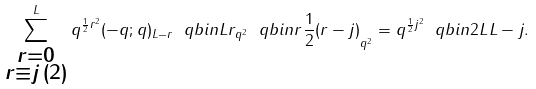Convert formula to latex. <formula><loc_0><loc_0><loc_500><loc_500>\sum _ { \substack { r = 0 \\ r \equiv j \, ( 2 ) } } ^ { L } q ^ { \frac { 1 } { 2 } r ^ { 2 } } ( - q ; q ) _ { L - r } \ q b i n { L } { r } _ { q ^ { 2 } } \ q b i n { r } { \frac { 1 } { 2 } ( r - j ) } _ { q ^ { 2 } } = q ^ { \frac { 1 } { 2 } j ^ { 2 } } \ q b i n { 2 L } { L - j } .</formula> 